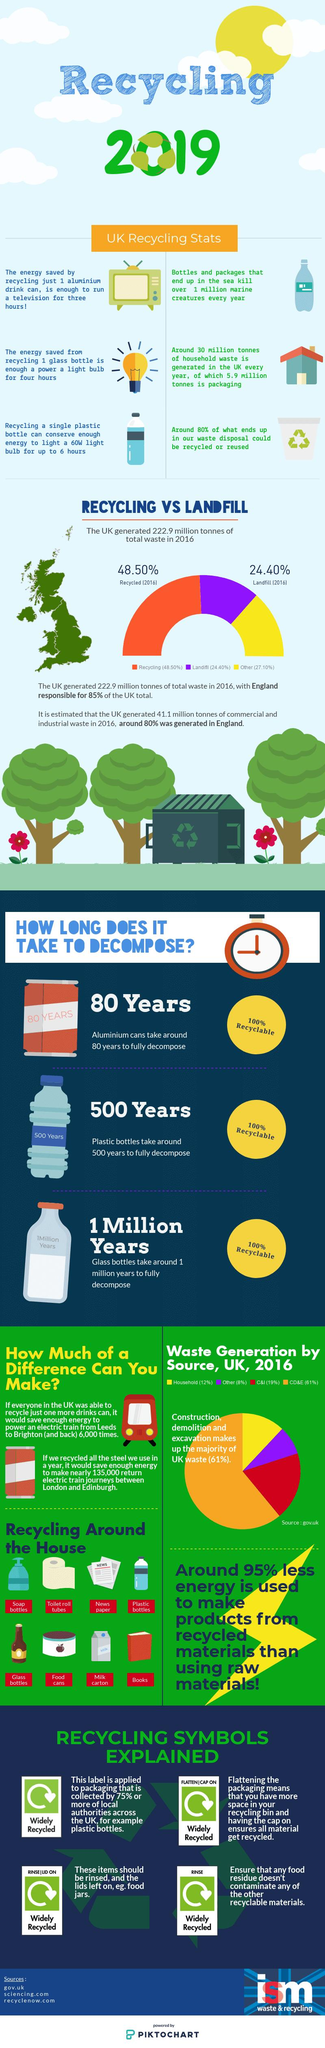Indicate a few pertinent items in this graphic. Glass bottles take the longest time to decompose among the three options: Glass bottles, Aluminium cans, and Plastic bottles. Orange color is the largest source of waste generation in the UK. The infographic explains four different recycling symbols. The yellow color in the graph represents the category of "Others," which includes various options that do not fit into the categories of Recycled or Landfill. According to the UK government's statistics, the source with the lowest percentage of waste generation is "Other. 